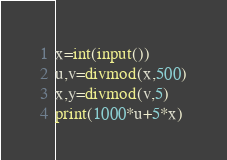<code> <loc_0><loc_0><loc_500><loc_500><_Python_>x=int(input())
u,v=divmod(x,500)
x,y=divmod(v,5)
print(1000*u+5*x)</code> 